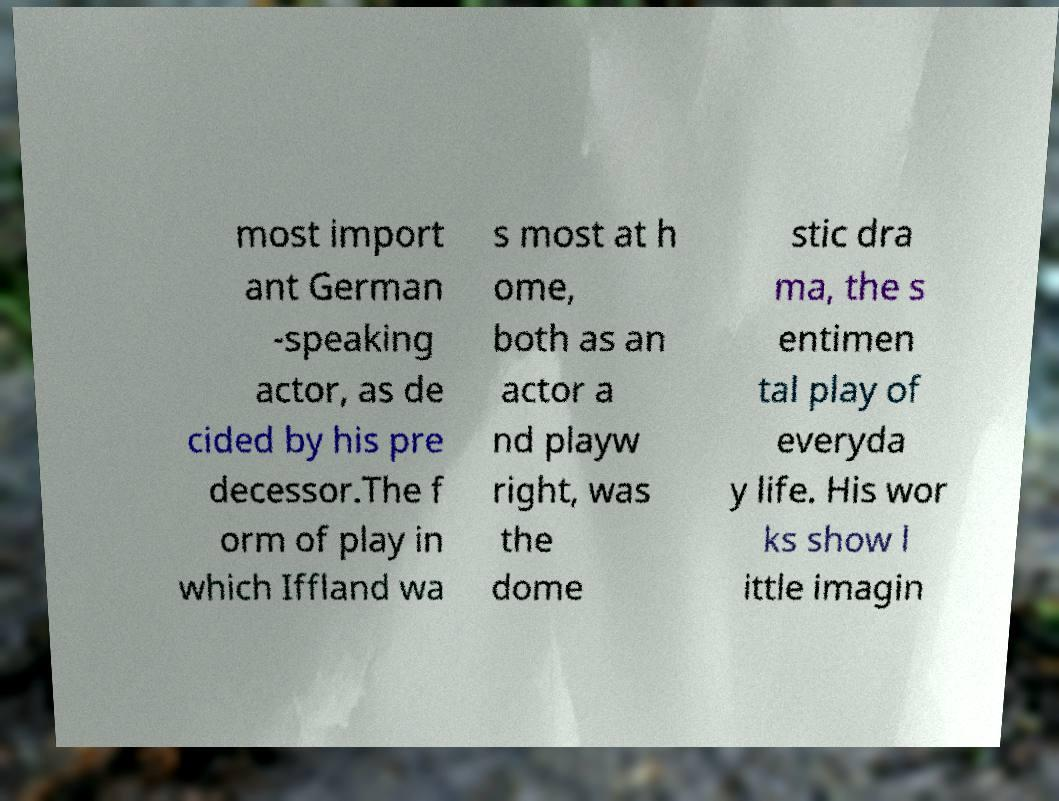What messages or text are displayed in this image? I need them in a readable, typed format. most import ant German -speaking actor, as de cided by his pre decessor.The f orm of play in which Iffland wa s most at h ome, both as an actor a nd playw right, was the dome stic dra ma, the s entimen tal play of everyda y life. His wor ks show l ittle imagin 